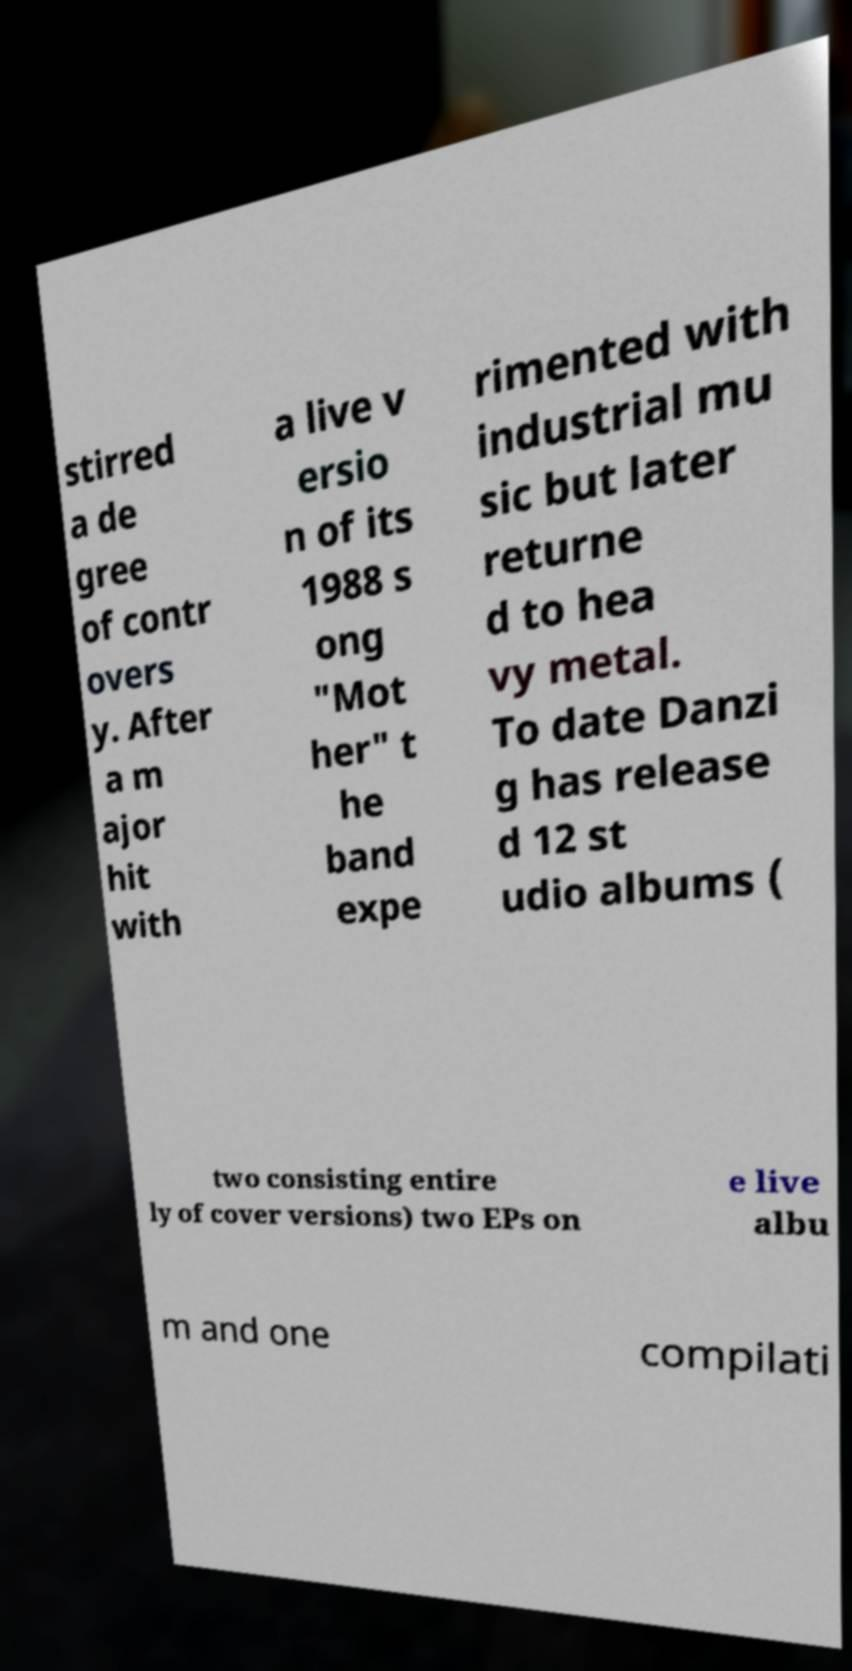Could you extract and type out the text from this image? stirred a de gree of contr overs y. After a m ajor hit with a live v ersio n of its 1988 s ong "Mot her" t he band expe rimented with industrial mu sic but later returne d to hea vy metal. To date Danzi g has release d 12 st udio albums ( two consisting entire ly of cover versions) two EPs on e live albu m and one compilati 